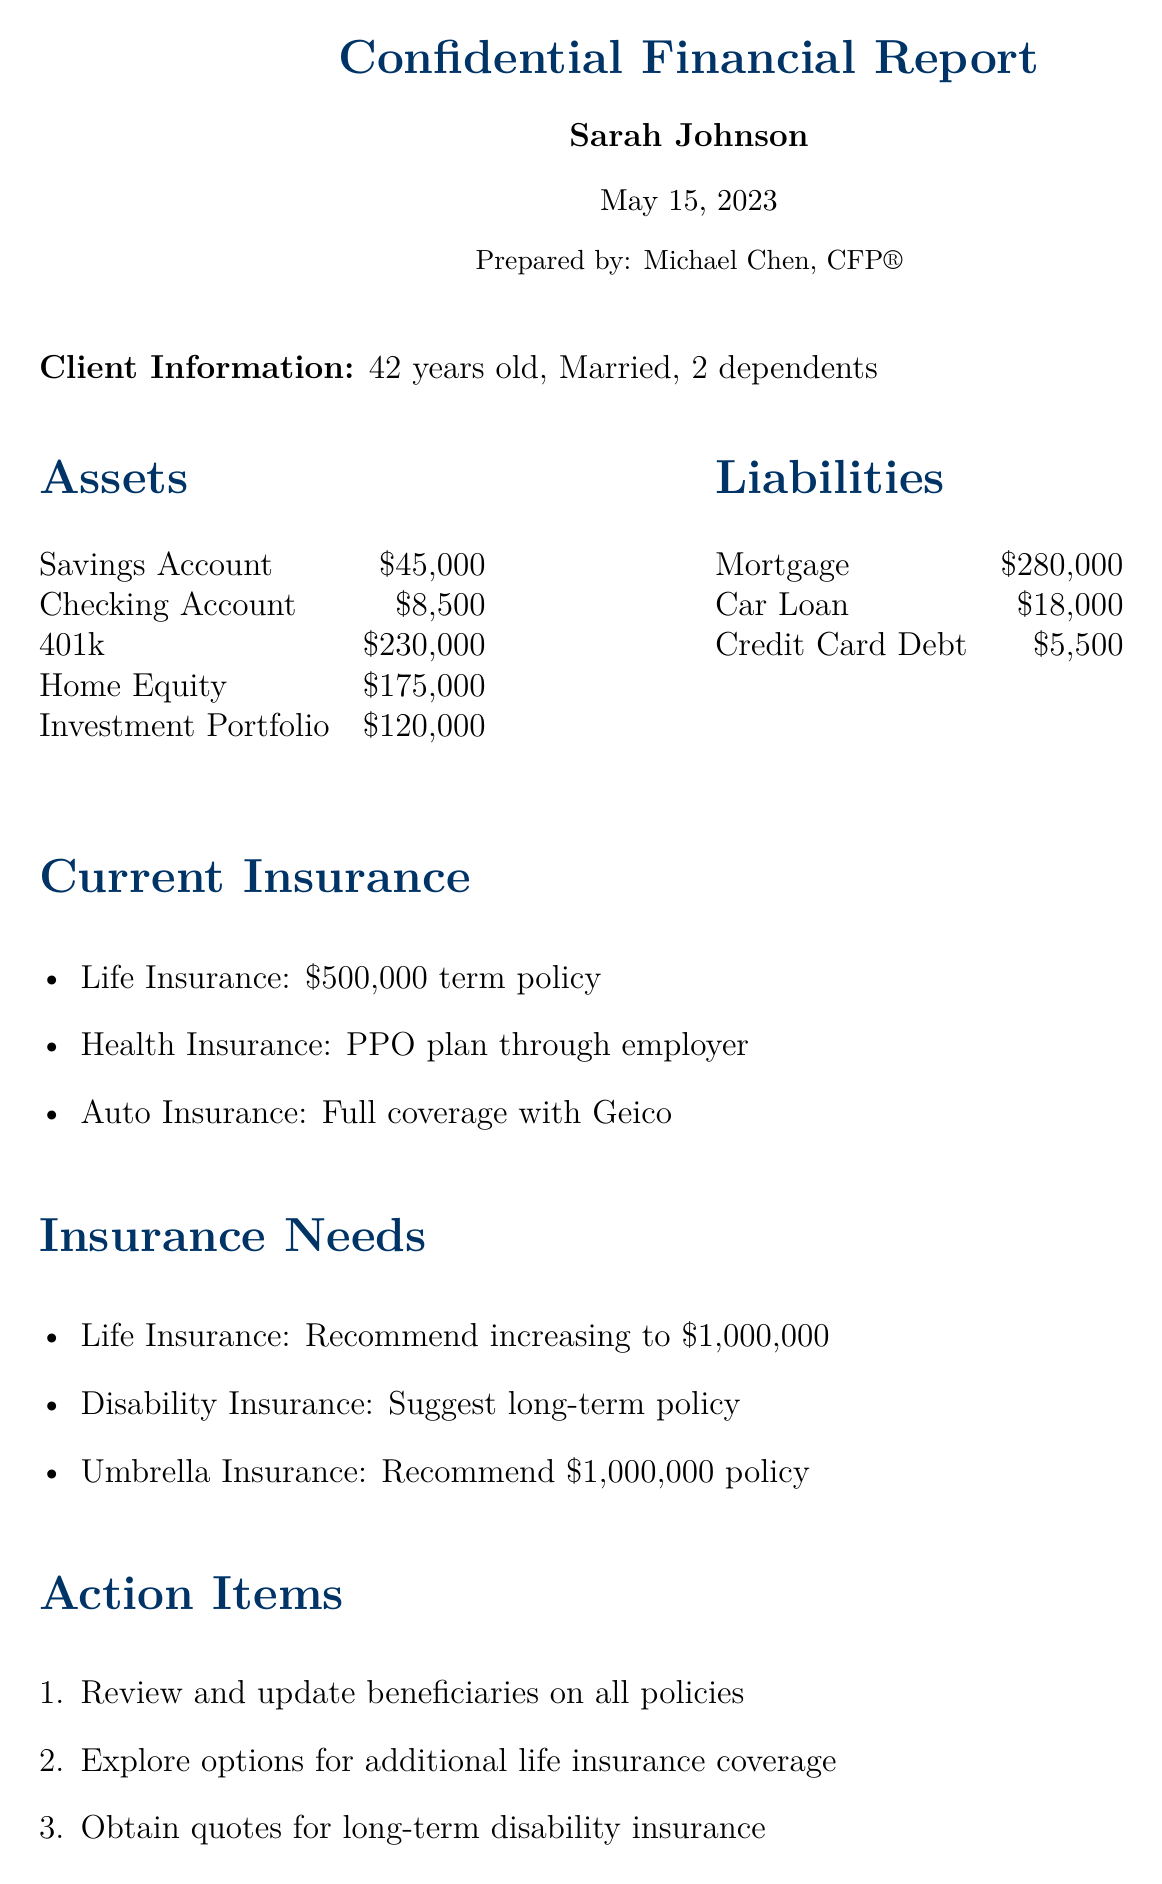What is the client's age? The document states the client is 42 years old.
Answer: 42 years old How much is in the savings account? The document lists the savings account balance as $45,000.
Answer: $45,000 What is the amount of the mortgage? The mortgage liability is specifically mentioned as $280,000.
Answer: $280,000 What type of insurance is recommended to increase? The document recommends increasing the life insurance coverage.
Answer: Life Insurance How much does the client currently have in life insurance? The current life insurance policy amount is mentioned as $500,000.
Answer: $500,000 What is the total value of the investment portfolio? The investment portfolio value is stated as $120,000 in the assets section.
Answer: $120,000 What is one suggested type of insurance to obtain? The document suggests obtaining long-term disability insurance.
Answer: Long-term disability insurance How many action items are listed in the document? The document outlines four action items in total.
Answer: 4 What is the suggested amount for the umbrella insurance policy? The recommendation for the umbrella insurance policy is $1,000,000.
Answer: $1,000,000 